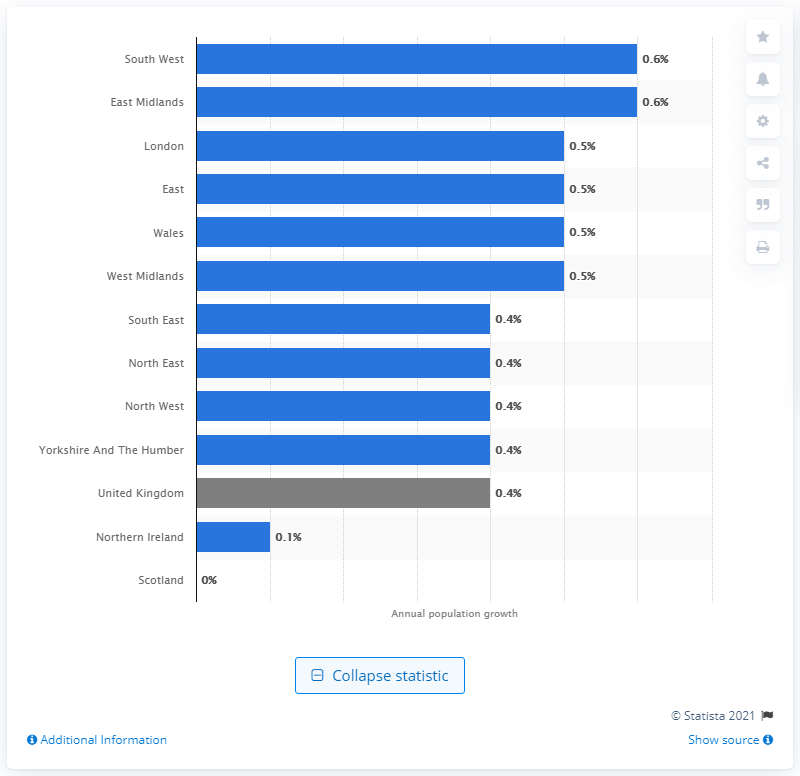Specify some key components in this picture. According to the data, the growth rate of Northern Ireland and Scotland in 2020 was 0.1%. The population of the UK grew by 0.4% in the year 2020. 